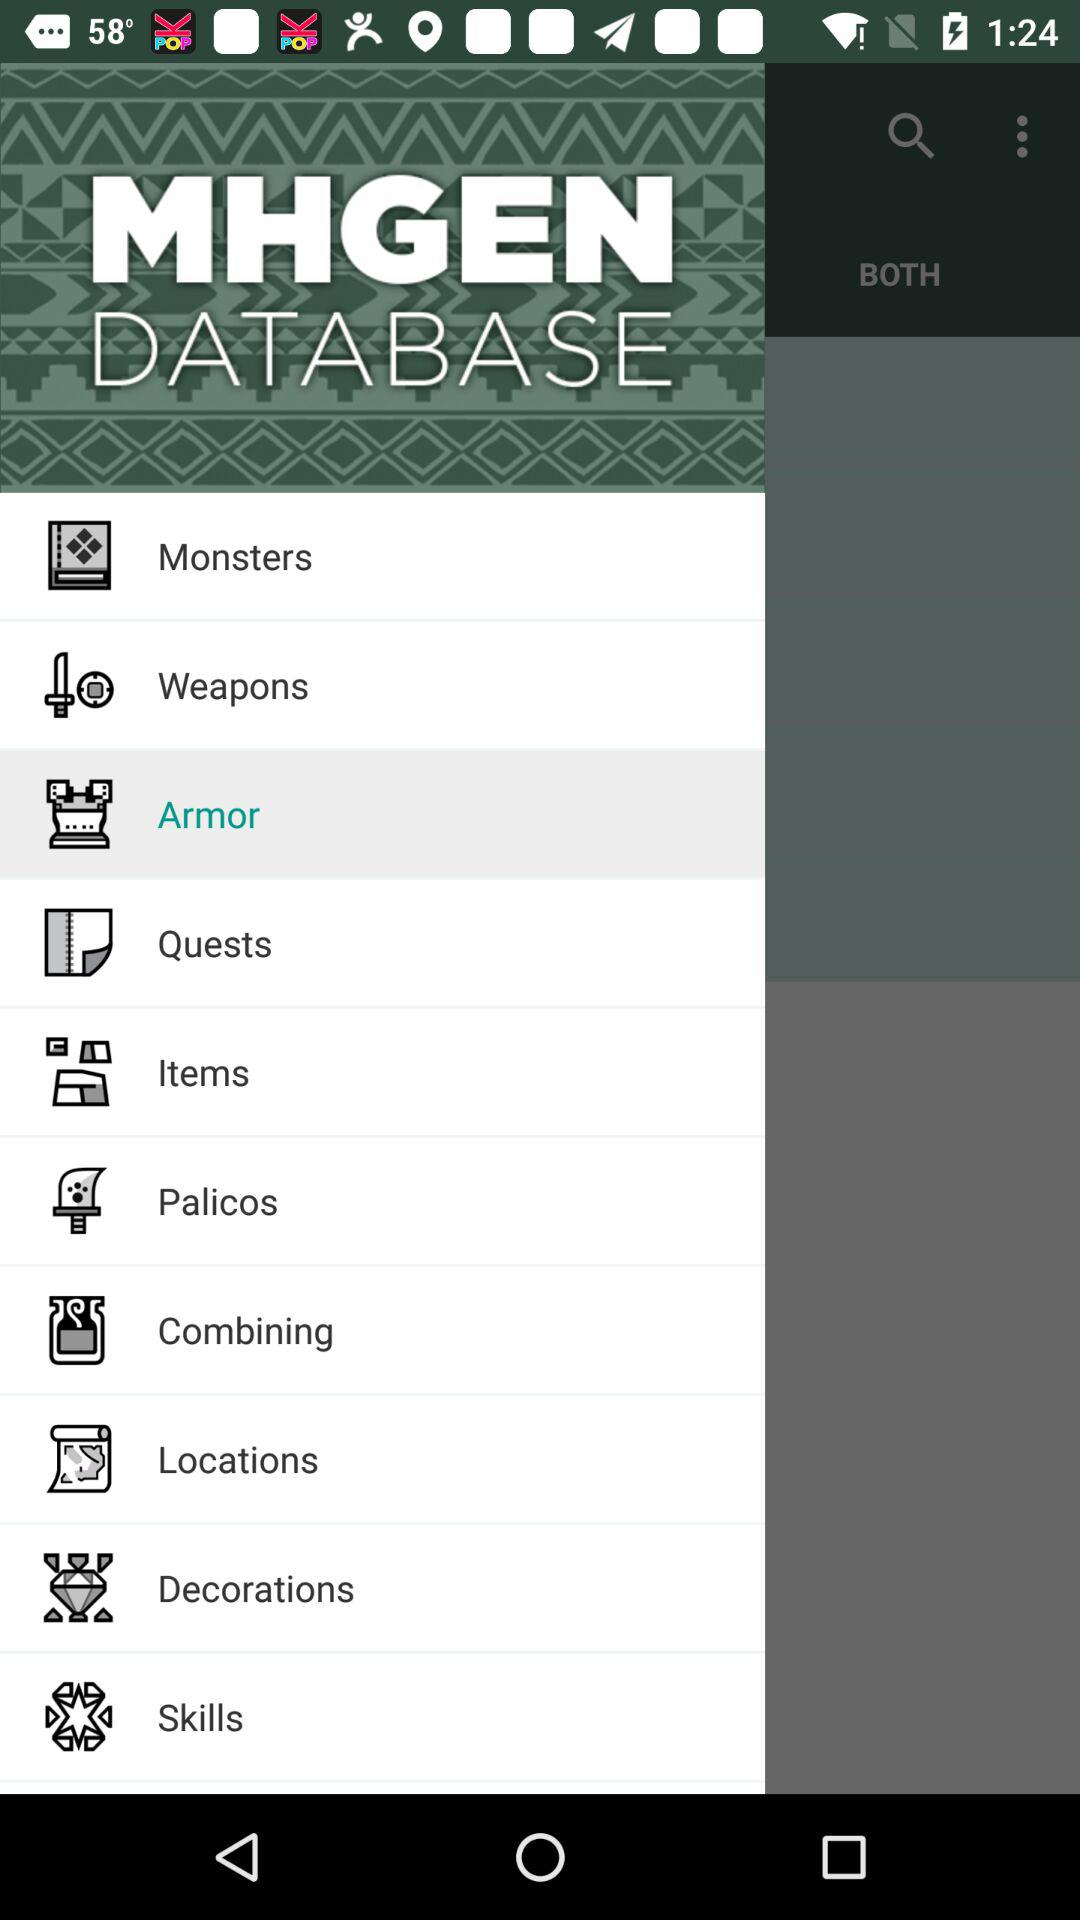Which option has been selected? The selected option is "Armor". 